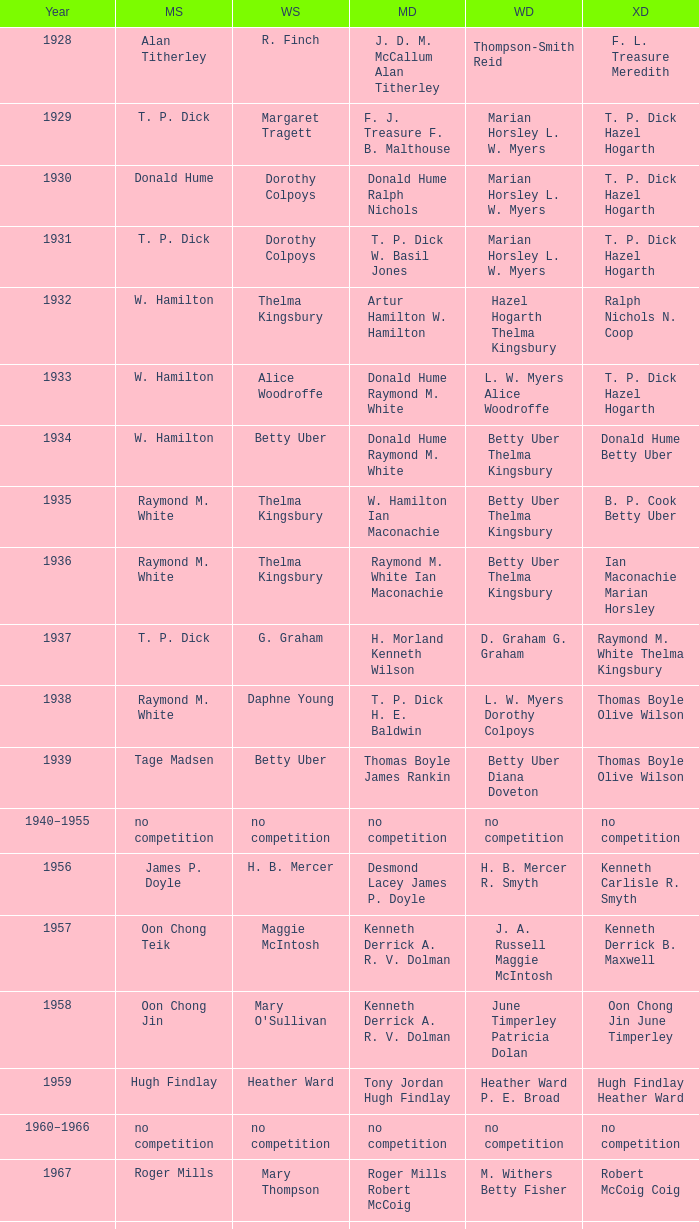Who won the Men's singles in the year that Ian Maconachie Marian Horsley won the Mixed doubles? Raymond M. White. 